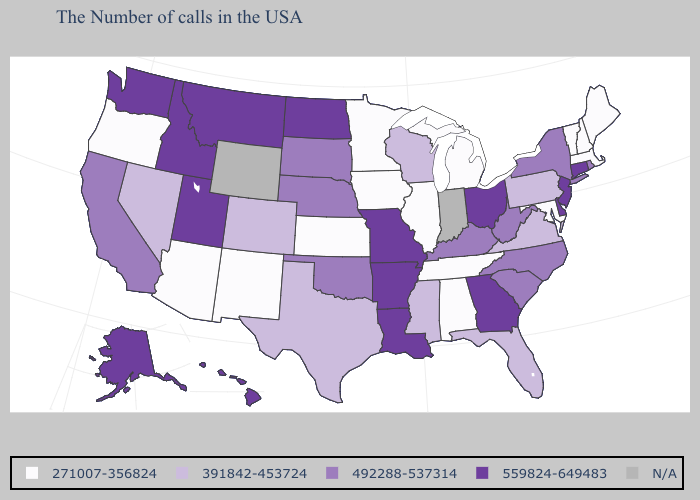What is the value of Minnesota?
Write a very short answer. 271007-356824. Name the states that have a value in the range 492288-537314?
Write a very short answer. Rhode Island, New York, North Carolina, South Carolina, West Virginia, Kentucky, Nebraska, Oklahoma, South Dakota, California. Which states have the lowest value in the MidWest?
Keep it brief. Michigan, Illinois, Minnesota, Iowa, Kansas. Name the states that have a value in the range N/A?
Quick response, please. Indiana, Wyoming. What is the value of West Virginia?
Answer briefly. 492288-537314. What is the highest value in the USA?
Answer briefly. 559824-649483. What is the highest value in states that border Connecticut?
Short answer required. 492288-537314. Does the first symbol in the legend represent the smallest category?
Write a very short answer. Yes. Name the states that have a value in the range 271007-356824?
Write a very short answer. Maine, Massachusetts, New Hampshire, Vermont, Maryland, Michigan, Alabama, Tennessee, Illinois, Minnesota, Iowa, Kansas, New Mexico, Arizona, Oregon. Does the first symbol in the legend represent the smallest category?
Quick response, please. Yes. Among the states that border Arizona , which have the highest value?
Quick response, please. Utah. Among the states that border South Carolina , does Georgia have the highest value?
Short answer required. Yes. Which states have the lowest value in the West?
Short answer required. New Mexico, Arizona, Oregon. Name the states that have a value in the range 492288-537314?
Keep it brief. Rhode Island, New York, North Carolina, South Carolina, West Virginia, Kentucky, Nebraska, Oklahoma, South Dakota, California. 